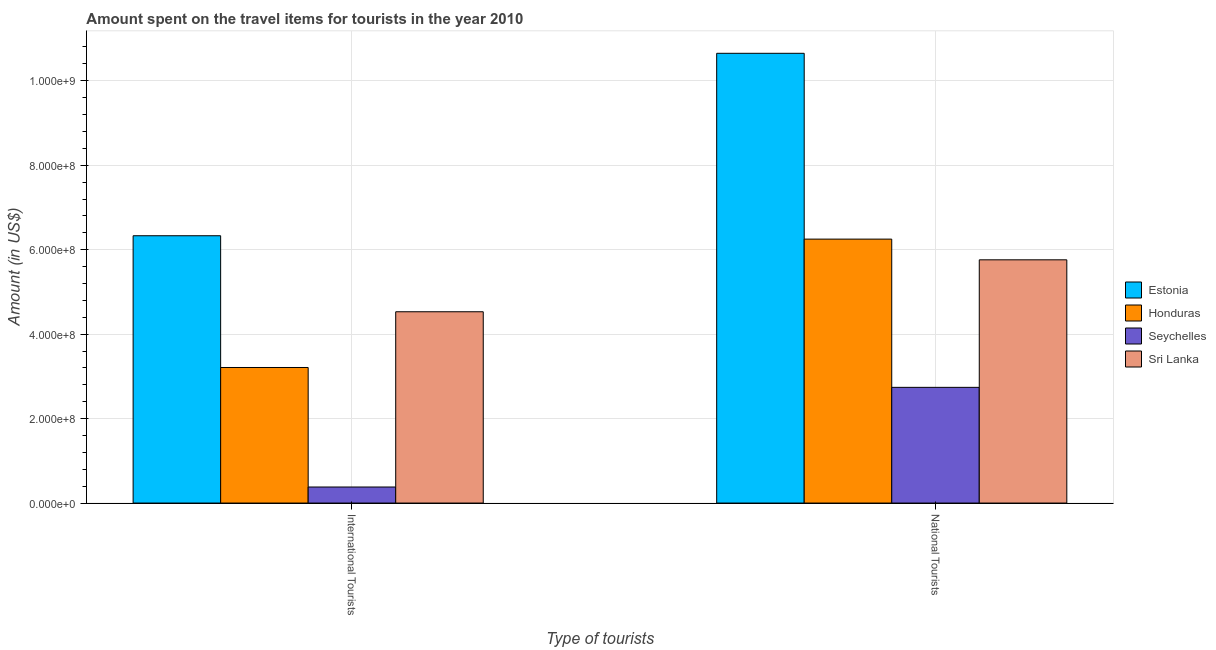How many groups of bars are there?
Your response must be concise. 2. Are the number of bars per tick equal to the number of legend labels?
Ensure brevity in your answer.  Yes. Are the number of bars on each tick of the X-axis equal?
Make the answer very short. Yes. How many bars are there on the 1st tick from the left?
Your answer should be very brief. 4. What is the label of the 1st group of bars from the left?
Offer a terse response. International Tourists. What is the amount spent on travel items of national tourists in Estonia?
Your answer should be compact. 1.06e+09. Across all countries, what is the maximum amount spent on travel items of national tourists?
Provide a succinct answer. 1.06e+09. Across all countries, what is the minimum amount spent on travel items of national tourists?
Offer a terse response. 2.74e+08. In which country was the amount spent on travel items of international tourists maximum?
Keep it short and to the point. Estonia. In which country was the amount spent on travel items of international tourists minimum?
Keep it short and to the point. Seychelles. What is the total amount spent on travel items of international tourists in the graph?
Your response must be concise. 1.44e+09. What is the difference between the amount spent on travel items of national tourists in Sri Lanka and that in Honduras?
Your response must be concise. -4.90e+07. What is the difference between the amount spent on travel items of international tourists in Seychelles and the amount spent on travel items of national tourists in Sri Lanka?
Make the answer very short. -5.38e+08. What is the average amount spent on travel items of national tourists per country?
Your response must be concise. 6.35e+08. What is the difference between the amount spent on travel items of national tourists and amount spent on travel items of international tourists in Estonia?
Offer a terse response. 4.32e+08. In how many countries, is the amount spent on travel items of national tourists greater than 80000000 US$?
Provide a short and direct response. 4. What is the ratio of the amount spent on travel items of international tourists in Estonia to that in Seychelles?
Provide a succinct answer. 16.66. Is the amount spent on travel items of national tourists in Honduras less than that in Estonia?
Keep it short and to the point. Yes. What does the 4th bar from the left in International Tourists represents?
Offer a very short reply. Sri Lanka. What does the 4th bar from the right in International Tourists represents?
Your answer should be very brief. Estonia. Are all the bars in the graph horizontal?
Give a very brief answer. No. What is the difference between two consecutive major ticks on the Y-axis?
Keep it short and to the point. 2.00e+08. Are the values on the major ticks of Y-axis written in scientific E-notation?
Keep it short and to the point. Yes. Does the graph contain grids?
Give a very brief answer. Yes. How many legend labels are there?
Give a very brief answer. 4. How are the legend labels stacked?
Your response must be concise. Vertical. What is the title of the graph?
Ensure brevity in your answer.  Amount spent on the travel items for tourists in the year 2010. Does "Peru" appear as one of the legend labels in the graph?
Ensure brevity in your answer.  No. What is the label or title of the X-axis?
Provide a succinct answer. Type of tourists. What is the Amount (in US$) of Estonia in International Tourists?
Your response must be concise. 6.33e+08. What is the Amount (in US$) in Honduras in International Tourists?
Give a very brief answer. 3.21e+08. What is the Amount (in US$) in Seychelles in International Tourists?
Your answer should be very brief. 3.80e+07. What is the Amount (in US$) in Sri Lanka in International Tourists?
Make the answer very short. 4.53e+08. What is the Amount (in US$) of Estonia in National Tourists?
Ensure brevity in your answer.  1.06e+09. What is the Amount (in US$) in Honduras in National Tourists?
Your answer should be compact. 6.25e+08. What is the Amount (in US$) in Seychelles in National Tourists?
Ensure brevity in your answer.  2.74e+08. What is the Amount (in US$) in Sri Lanka in National Tourists?
Offer a terse response. 5.76e+08. Across all Type of tourists, what is the maximum Amount (in US$) of Estonia?
Your answer should be very brief. 1.06e+09. Across all Type of tourists, what is the maximum Amount (in US$) of Honduras?
Your response must be concise. 6.25e+08. Across all Type of tourists, what is the maximum Amount (in US$) in Seychelles?
Provide a succinct answer. 2.74e+08. Across all Type of tourists, what is the maximum Amount (in US$) in Sri Lanka?
Give a very brief answer. 5.76e+08. Across all Type of tourists, what is the minimum Amount (in US$) of Estonia?
Make the answer very short. 6.33e+08. Across all Type of tourists, what is the minimum Amount (in US$) in Honduras?
Keep it short and to the point. 3.21e+08. Across all Type of tourists, what is the minimum Amount (in US$) in Seychelles?
Keep it short and to the point. 3.80e+07. Across all Type of tourists, what is the minimum Amount (in US$) in Sri Lanka?
Provide a short and direct response. 4.53e+08. What is the total Amount (in US$) of Estonia in the graph?
Offer a very short reply. 1.70e+09. What is the total Amount (in US$) of Honduras in the graph?
Offer a terse response. 9.46e+08. What is the total Amount (in US$) in Seychelles in the graph?
Offer a very short reply. 3.12e+08. What is the total Amount (in US$) of Sri Lanka in the graph?
Your response must be concise. 1.03e+09. What is the difference between the Amount (in US$) in Estonia in International Tourists and that in National Tourists?
Keep it short and to the point. -4.32e+08. What is the difference between the Amount (in US$) in Honduras in International Tourists and that in National Tourists?
Your answer should be compact. -3.04e+08. What is the difference between the Amount (in US$) in Seychelles in International Tourists and that in National Tourists?
Provide a succinct answer. -2.36e+08. What is the difference between the Amount (in US$) of Sri Lanka in International Tourists and that in National Tourists?
Offer a terse response. -1.23e+08. What is the difference between the Amount (in US$) of Estonia in International Tourists and the Amount (in US$) of Seychelles in National Tourists?
Make the answer very short. 3.59e+08. What is the difference between the Amount (in US$) of Estonia in International Tourists and the Amount (in US$) of Sri Lanka in National Tourists?
Provide a short and direct response. 5.70e+07. What is the difference between the Amount (in US$) in Honduras in International Tourists and the Amount (in US$) in Seychelles in National Tourists?
Keep it short and to the point. 4.70e+07. What is the difference between the Amount (in US$) of Honduras in International Tourists and the Amount (in US$) of Sri Lanka in National Tourists?
Your response must be concise. -2.55e+08. What is the difference between the Amount (in US$) in Seychelles in International Tourists and the Amount (in US$) in Sri Lanka in National Tourists?
Provide a succinct answer. -5.38e+08. What is the average Amount (in US$) in Estonia per Type of tourists?
Give a very brief answer. 8.49e+08. What is the average Amount (in US$) of Honduras per Type of tourists?
Your response must be concise. 4.73e+08. What is the average Amount (in US$) in Seychelles per Type of tourists?
Keep it short and to the point. 1.56e+08. What is the average Amount (in US$) in Sri Lanka per Type of tourists?
Your answer should be compact. 5.14e+08. What is the difference between the Amount (in US$) in Estonia and Amount (in US$) in Honduras in International Tourists?
Give a very brief answer. 3.12e+08. What is the difference between the Amount (in US$) in Estonia and Amount (in US$) in Seychelles in International Tourists?
Make the answer very short. 5.95e+08. What is the difference between the Amount (in US$) in Estonia and Amount (in US$) in Sri Lanka in International Tourists?
Provide a succinct answer. 1.80e+08. What is the difference between the Amount (in US$) in Honduras and Amount (in US$) in Seychelles in International Tourists?
Ensure brevity in your answer.  2.83e+08. What is the difference between the Amount (in US$) in Honduras and Amount (in US$) in Sri Lanka in International Tourists?
Keep it short and to the point. -1.32e+08. What is the difference between the Amount (in US$) in Seychelles and Amount (in US$) in Sri Lanka in International Tourists?
Your answer should be compact. -4.15e+08. What is the difference between the Amount (in US$) in Estonia and Amount (in US$) in Honduras in National Tourists?
Offer a very short reply. 4.40e+08. What is the difference between the Amount (in US$) in Estonia and Amount (in US$) in Seychelles in National Tourists?
Offer a terse response. 7.91e+08. What is the difference between the Amount (in US$) in Estonia and Amount (in US$) in Sri Lanka in National Tourists?
Offer a very short reply. 4.89e+08. What is the difference between the Amount (in US$) of Honduras and Amount (in US$) of Seychelles in National Tourists?
Offer a very short reply. 3.51e+08. What is the difference between the Amount (in US$) in Honduras and Amount (in US$) in Sri Lanka in National Tourists?
Your answer should be very brief. 4.90e+07. What is the difference between the Amount (in US$) of Seychelles and Amount (in US$) of Sri Lanka in National Tourists?
Your answer should be very brief. -3.02e+08. What is the ratio of the Amount (in US$) in Estonia in International Tourists to that in National Tourists?
Make the answer very short. 0.59. What is the ratio of the Amount (in US$) of Honduras in International Tourists to that in National Tourists?
Your answer should be very brief. 0.51. What is the ratio of the Amount (in US$) in Seychelles in International Tourists to that in National Tourists?
Offer a terse response. 0.14. What is the ratio of the Amount (in US$) in Sri Lanka in International Tourists to that in National Tourists?
Your answer should be very brief. 0.79. What is the difference between the highest and the second highest Amount (in US$) in Estonia?
Make the answer very short. 4.32e+08. What is the difference between the highest and the second highest Amount (in US$) in Honduras?
Make the answer very short. 3.04e+08. What is the difference between the highest and the second highest Amount (in US$) in Seychelles?
Your response must be concise. 2.36e+08. What is the difference between the highest and the second highest Amount (in US$) of Sri Lanka?
Your answer should be compact. 1.23e+08. What is the difference between the highest and the lowest Amount (in US$) of Estonia?
Make the answer very short. 4.32e+08. What is the difference between the highest and the lowest Amount (in US$) of Honduras?
Offer a very short reply. 3.04e+08. What is the difference between the highest and the lowest Amount (in US$) in Seychelles?
Your answer should be very brief. 2.36e+08. What is the difference between the highest and the lowest Amount (in US$) of Sri Lanka?
Keep it short and to the point. 1.23e+08. 